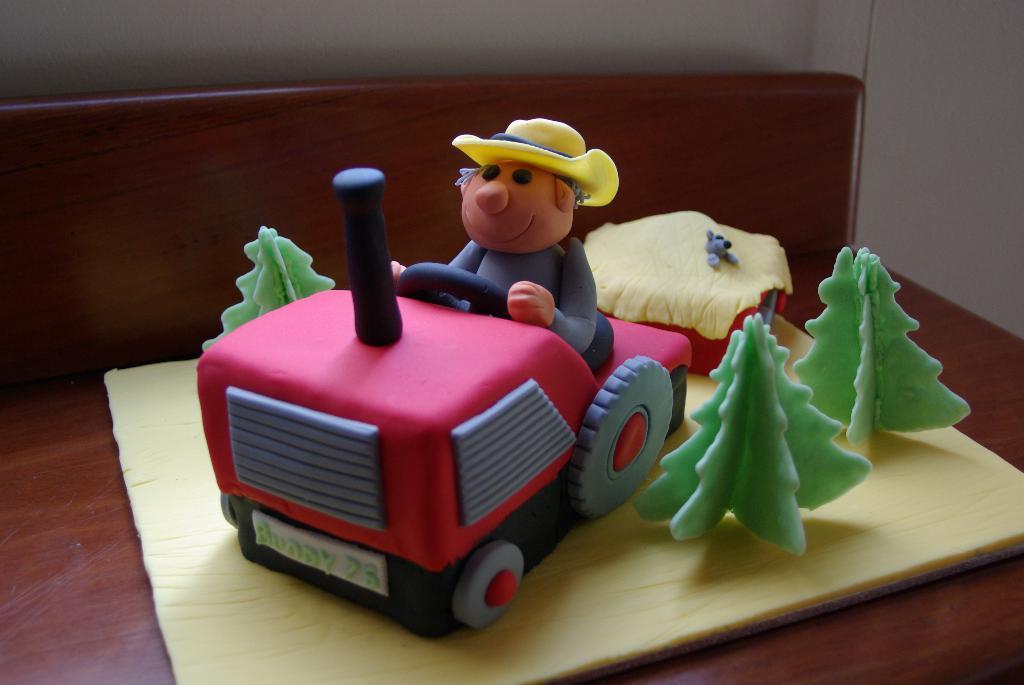In one or two sentences, can you explain what this image depicts? In this image I see the brown color surface on which there are things made with clay in which I see a vehicle on which there is a man sitting on it and I see 3 trees and I see a thing over here. 